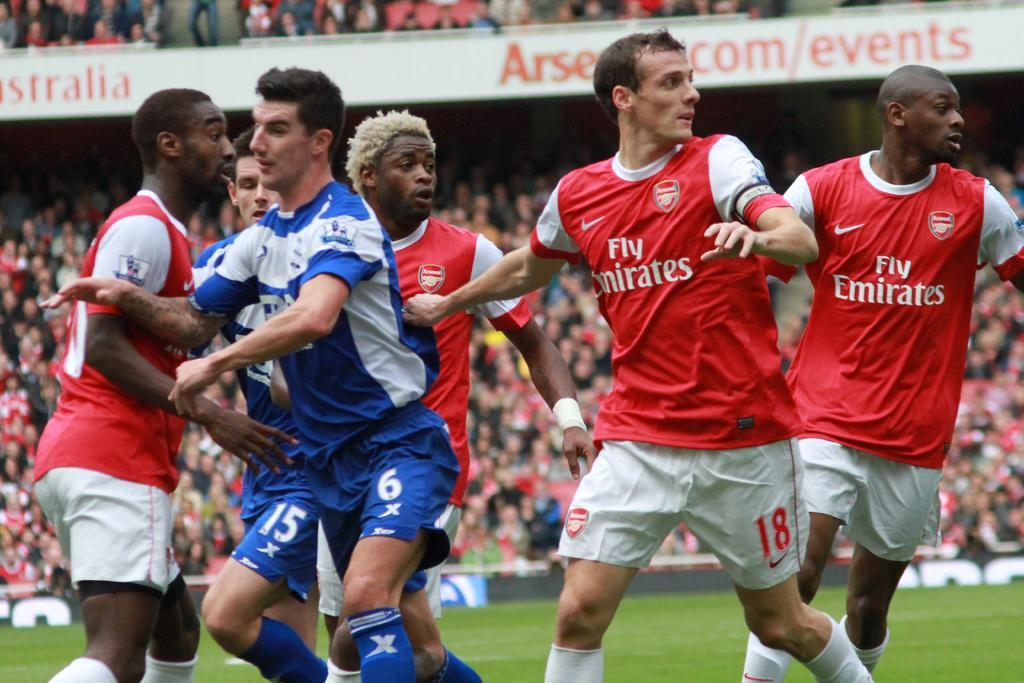Provide a one-sentence caption for the provided image. The red team is sponsored by Emirates and they are playing the blue team. 